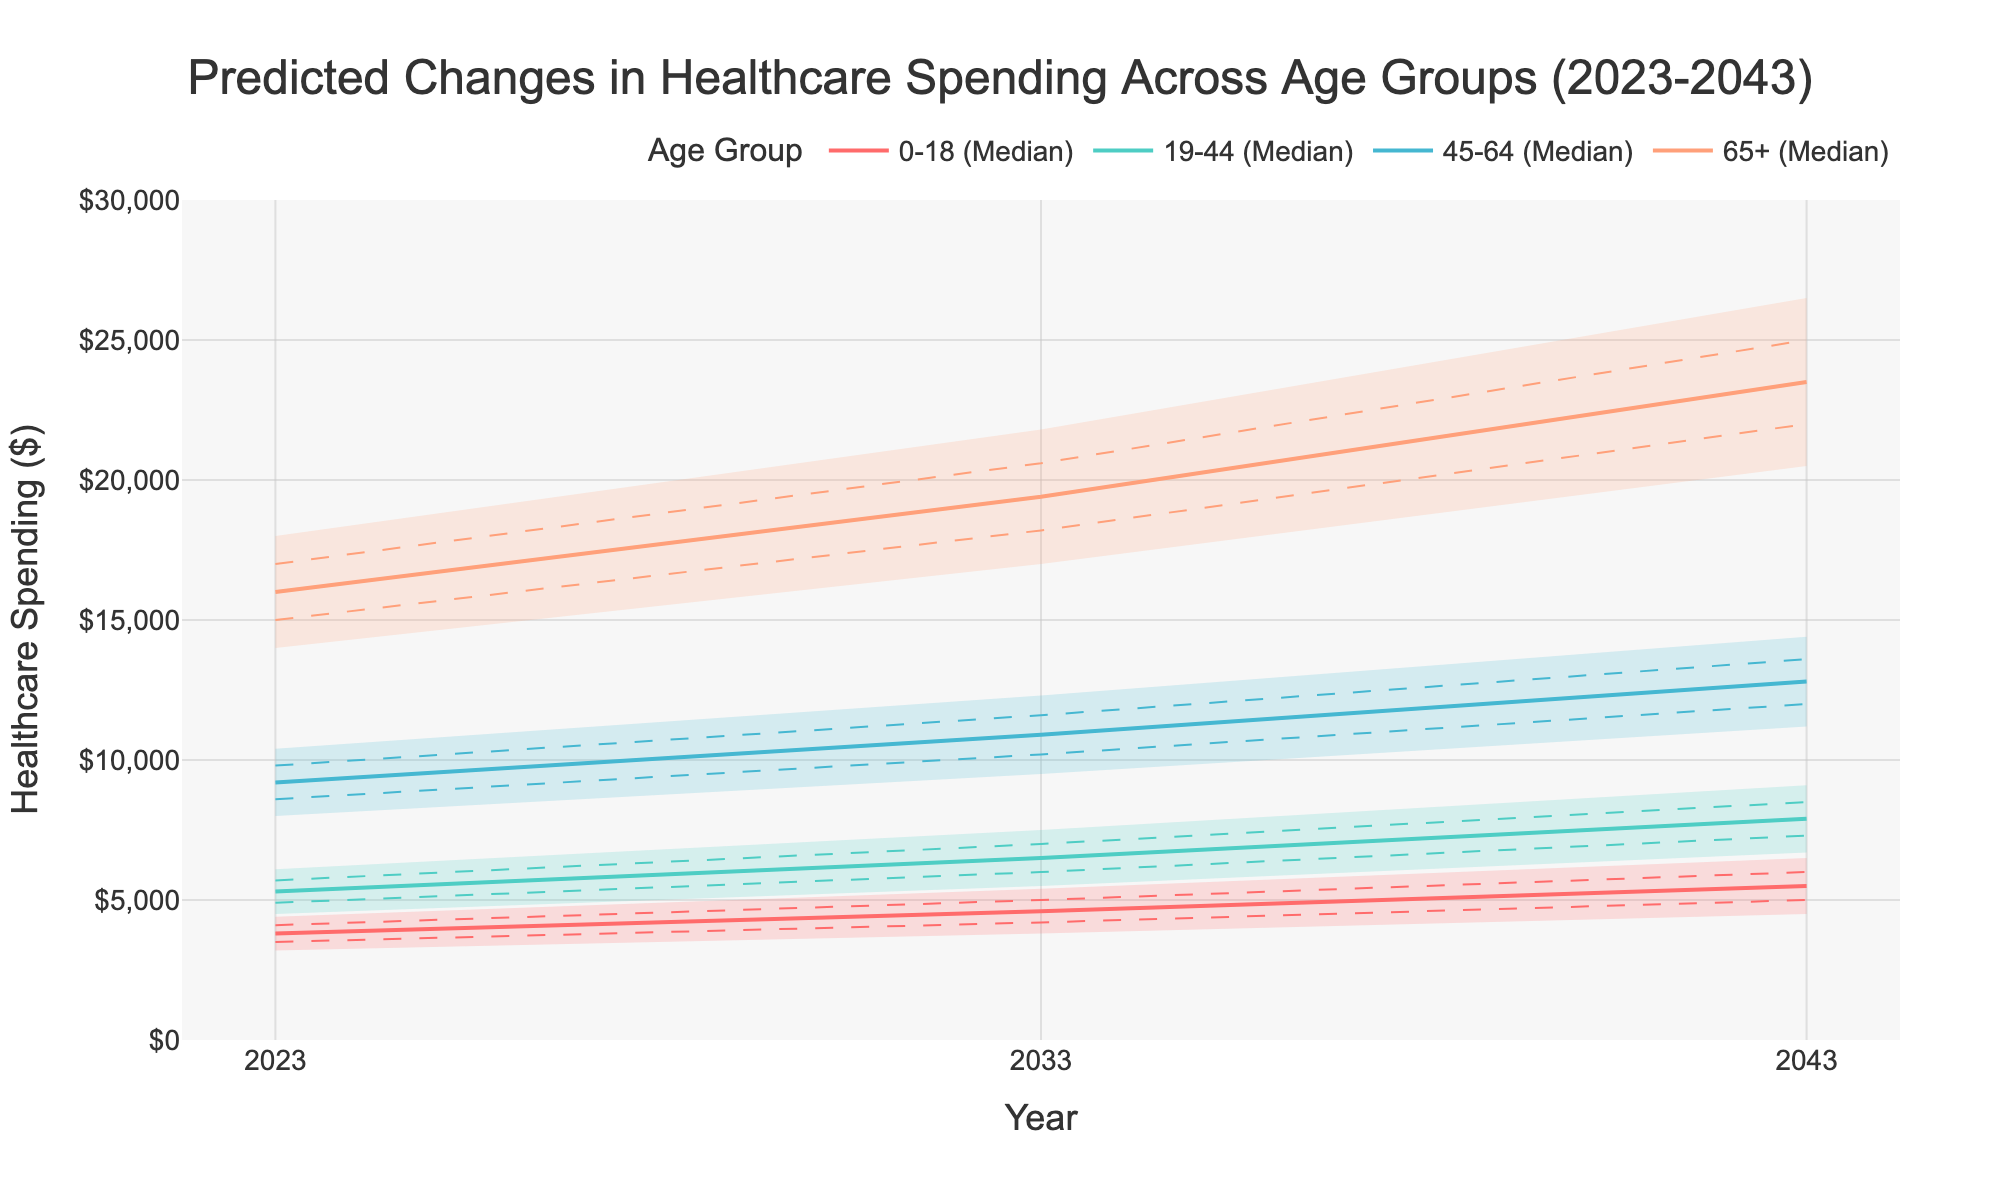What is the title of the figure? The title is located at the top of the figure and is given in large, bold font for easy identification.
Answer: "Predicted Changes in Healthcare Spending Across Age Groups (2023-2043)" What is the healthcare spending prediction for the 0-18 age group in the year 2033 at the median level? Look for the 0-18 age group predictions for the year 2033 and find the median value.
Answer: $4600 Which age group has the highest median healthcare spending in the year 2043? Compare the median healthcare spending values for all the age groups in 2043 to identify the highest one.
Answer: 65+ How does the median healthcare spending for the 19-44 age group change from 2023 to 2043? Subtract the median value for 2023 from the median value for 2043 within the 19-44 age group to determine the change.
Answer: $2600 Compare the upper bound of healthcare spending for the 45-64 age group in 2023 to the lower bound for the same group in 2043. Which is higher? Check the upper bound for the 45-64 age group in 2023 and the lower bound for the same group in 2043 and compare them.
Answer: 2043 lower bound In 2033, what is the range of predicted healthcare spending for the 65+ age group? Deduct the lower bound from the upper bound for the 65+ age group in 2033.
Answer: $4800 Which age group has the narrowest prediction interval in 2023? Compare the difference between the upper and lower bounds for all age groups in 2023 to find the smallest difference.
Answer: 0-18 From 2023 to 2043, which age group sees the largest increase in median healthcare spending? Calculate the difference between the 2023 and 2043 median values for each age group and find the largest increase.
Answer: 65+ What colors are used to represent the age groups in the figure? Identify the colors used to draw the lines corresponding to the different age groups in the plot.
Answer: Red, Teal, Blue, Light Salmon How does the median healthcare spending for the 0-18 age group in 2023 compare to the lower middle prediction for the same group in 2043? Compare the median value of 2023 with the lower middle value of 2043 for the 0-18 age group to see which is higher.
Answer: Lower Middle 2043 